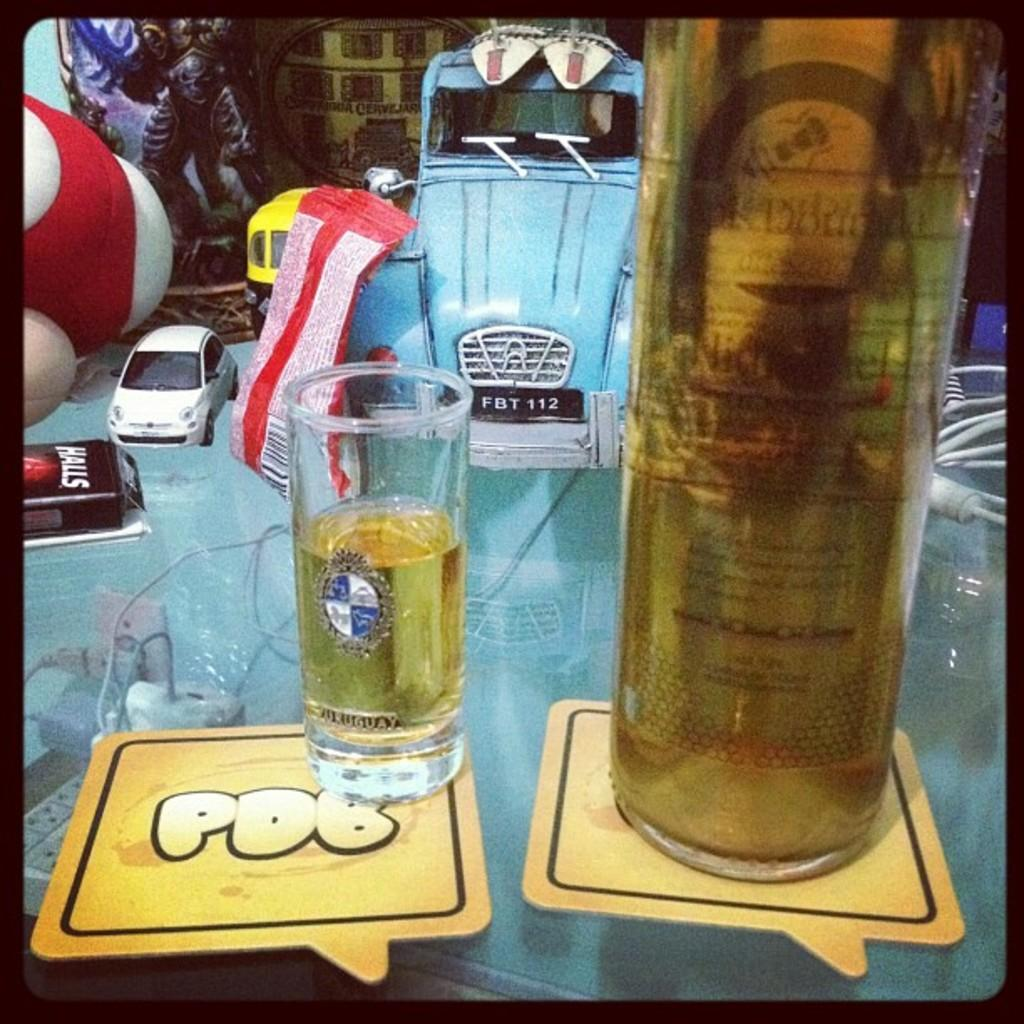Provide a one-sentence caption for the provided image. A table full or random items has a PDB coaster on it with a shot on top. 